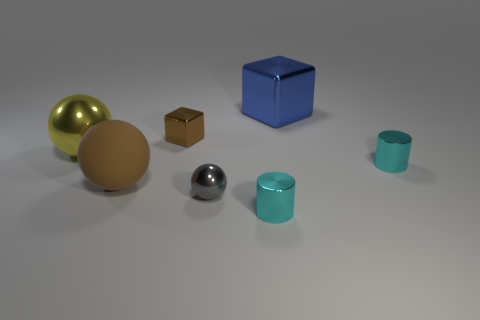What shape is the brown object that is in front of the big shiny object to the left of the brown thing behind the yellow metal thing? The brown object in front of the big shiny one to the left of the brown thing behind the yellow metal object is a sphere, more specifically a ball or orb-like shape. 